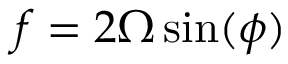Convert formula to latex. <formula><loc_0><loc_0><loc_500><loc_500>f = 2 \Omega \sin ( \phi )</formula> 